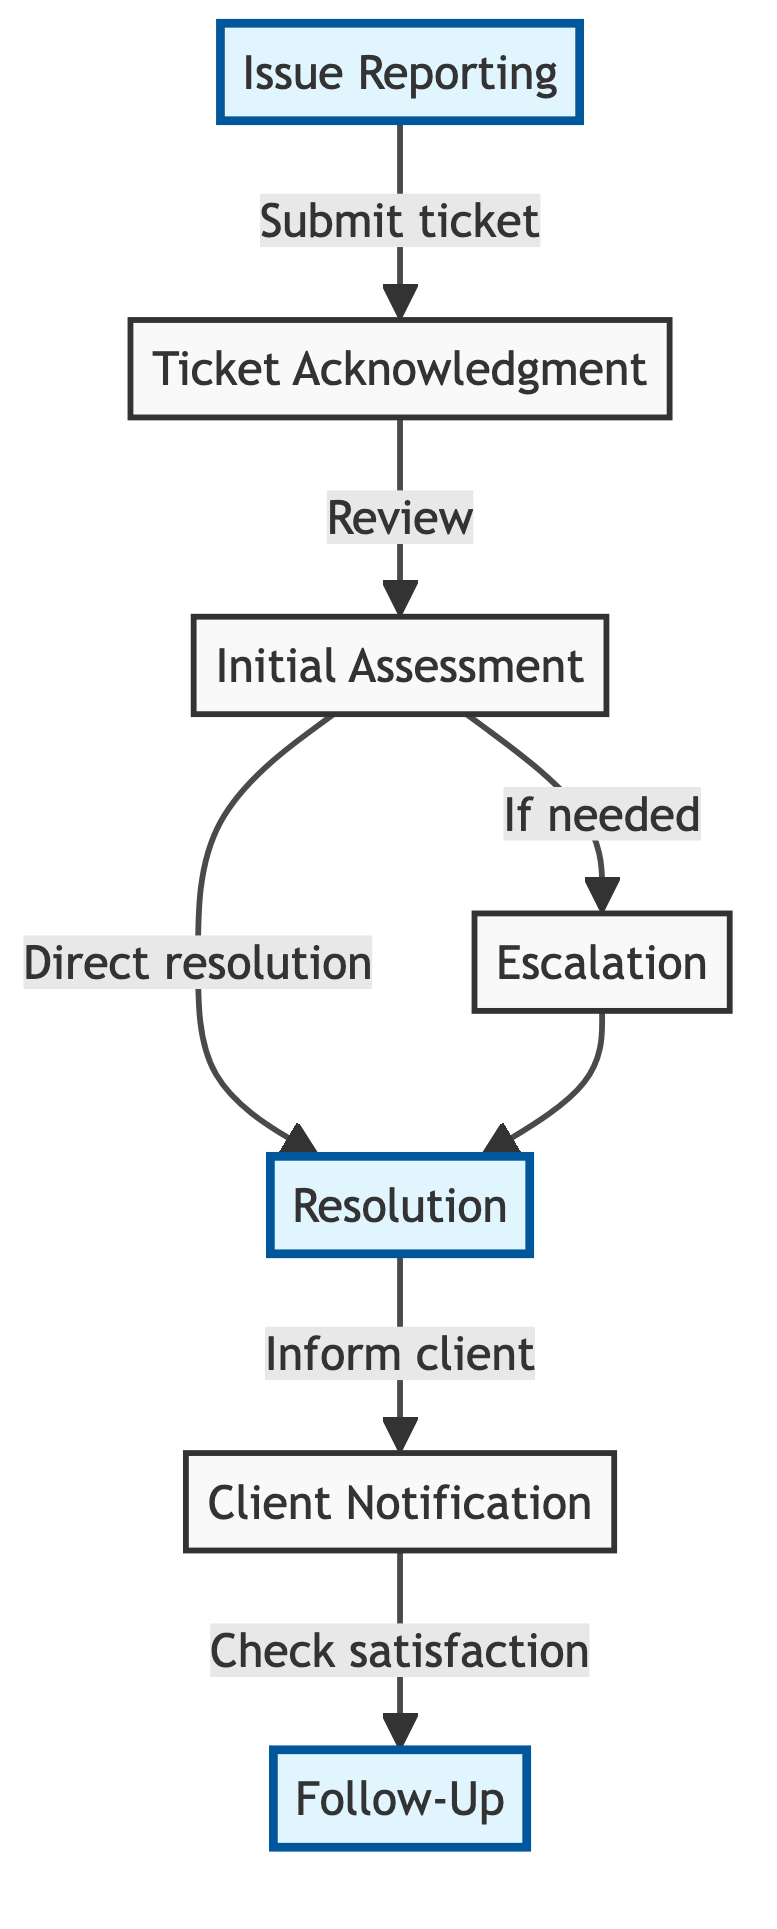What is the first stage in the client support ticket process? The flow chart begins with the "Issue Reporting" stage, clearly labeled at the top of the diagram. This indicates that clients start the process by submitting a support ticket.
Answer: Issue Reporting How many stages are there in the client support ticket process? Counting the stages listed in the flow chart, we have a total of seven stages: Issue Reporting, Ticket Acknowledgment, Initial Assessment, Escalation, Resolution, Client Notification, and Follow-Up.
Answer: 7 What is the outcome of the "Initial Assessment" stage if the issue is not escalated? If the issue is categorized during the "Initial Assessment," and does not require escalation, the flow indicates a direct path to the "Resolution" stage. This means the ticket can be resolved without further escalation.
Answer: Resolution Which stage comes after "Client Notification"? After the "Client Notification" stage, the flow chart leads to the "Follow-Up" stage, indicating that support checks in with the client post-resolution.
Answer: Follow-Up What stage requires escalation if necessary? The "Escalation" stage is specifically mentioned for tickets that need to be escalated to a specialized support team, showing that it's contingent on the initial assessment.
Answer: Escalation 